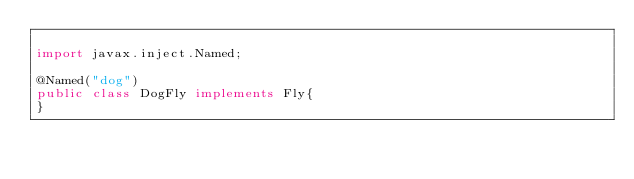Convert code to text. <code><loc_0><loc_0><loc_500><loc_500><_Java_>
import javax.inject.Named;

@Named("dog")
public class DogFly implements Fly{
}
</code> 